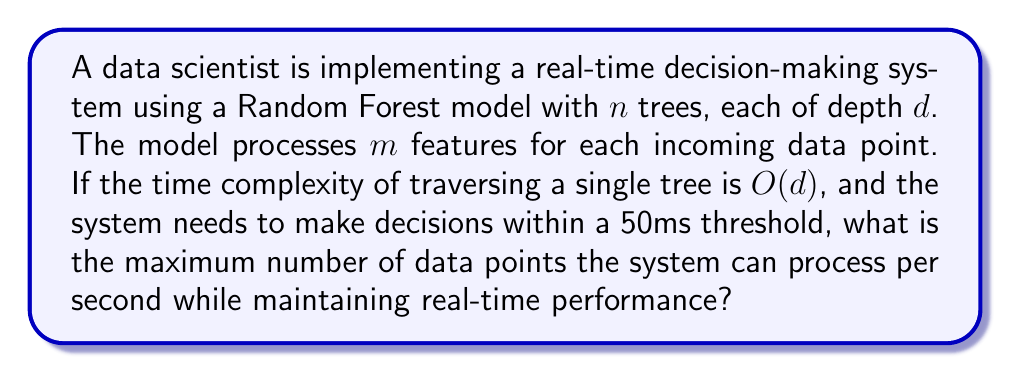Help me with this question. To solve this problem, we need to follow these steps:

1. Calculate the time complexity of the Random Forest model:
   - For a single tree: $O(d)$
   - For $n$ trees: $O(n \cdot d)$
   - Processing $m$ features: $O(m \cdot n \cdot d)$

2. Convert the time threshold to seconds:
   50ms = 0.05 seconds

3. Calculate the maximum number of data points that can be processed in one second:

Let $x$ be the number of data points processed per second.

The time taken to process $x$ data points should be less than or equal to 1 second:

$$ x \cdot k \cdot m \cdot n \cdot d \leq 1 $$

Where $k$ is a constant factor representing the actual time taken by each operation.

4. Solve for $x$:

$$ x \leq \frac{1}{k \cdot m \cdot n \cdot d} $$

5. To maintain real-time performance, we need to ensure that each data point is processed within the 50ms threshold:

$$ \frac{1}{x} \geq 0.05 \text{ seconds} $$

Substituting the inequality from step 4:

$$ k \cdot m \cdot n \cdot d \geq 0.05 $$

6. The maximum number of data points that can be processed per second while maintaining real-time performance is:

$$ x = \min(\frac{1}{k \cdot m \cdot n \cdot d}, 20) $$

The actual value depends on the specific values of $k$, $m$, $n$, and $d$, which are not provided in the question. However, we can conclude that the maximum number of data points processed per second is the smaller of $\frac{1}{k \cdot m \cdot n \cdot d}$ and 20 (as 1/0.05 = 20).
Answer: The maximum number of data points the system can process per second while maintaining real-time performance is $\min(\frac{1}{k \cdot m \cdot n \cdot d}, 20)$, where $k$ is a constant factor, $m$ is the number of features, $n$ is the number of trees, and $d$ is the depth of each tree in the Random Forest model. 